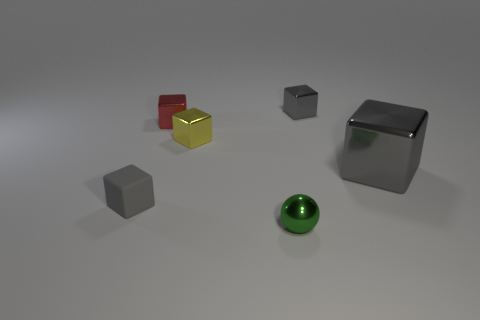Is there any other thing that is the same shape as the small green shiny object?
Ensure brevity in your answer.  No. There is a tiny ball; is its color the same as the tiny metal block that is on the right side of the green metal object?
Your answer should be very brief. No. How many small metal spheres have the same color as the tiny rubber cube?
Ensure brevity in your answer.  0. There is a shiny thing in front of the large metal block behind the small rubber thing; how big is it?
Provide a succinct answer. Small. What number of objects are gray shiny blocks in front of the yellow shiny object or small green metal balls?
Provide a short and direct response. 2. Are there any yellow cubes of the same size as the gray matte object?
Offer a very short reply. Yes. Is there a small green sphere right of the thing behind the tiny red cube?
Your answer should be very brief. No. What number of balls are cyan objects or large metal things?
Provide a succinct answer. 0. Are there any gray matte things of the same shape as the yellow metal thing?
Make the answer very short. Yes. The large metal thing has what shape?
Your response must be concise. Cube. 